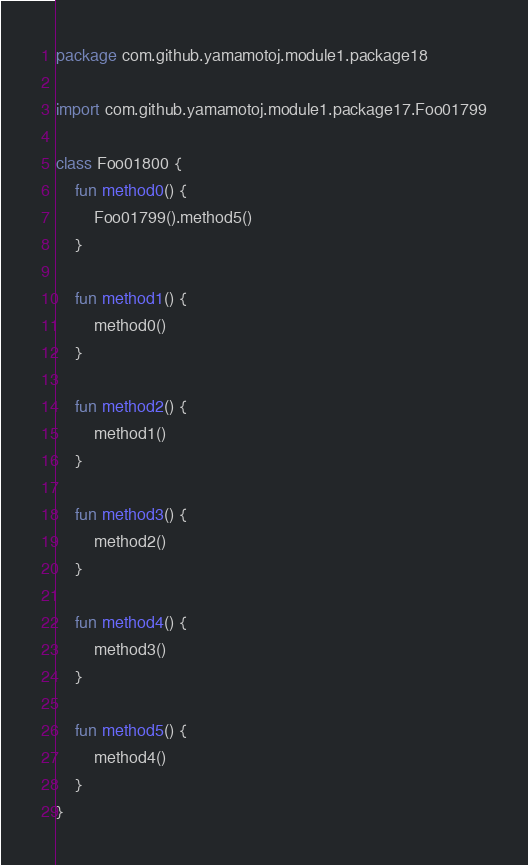<code> <loc_0><loc_0><loc_500><loc_500><_Kotlin_>package com.github.yamamotoj.module1.package18

import com.github.yamamotoj.module1.package17.Foo01799

class Foo01800 {
    fun method0() {
        Foo01799().method5()
    }

    fun method1() {
        method0()
    }

    fun method2() {
        method1()
    }

    fun method3() {
        method2()
    }

    fun method4() {
        method3()
    }

    fun method5() {
        method4()
    }
}
</code> 